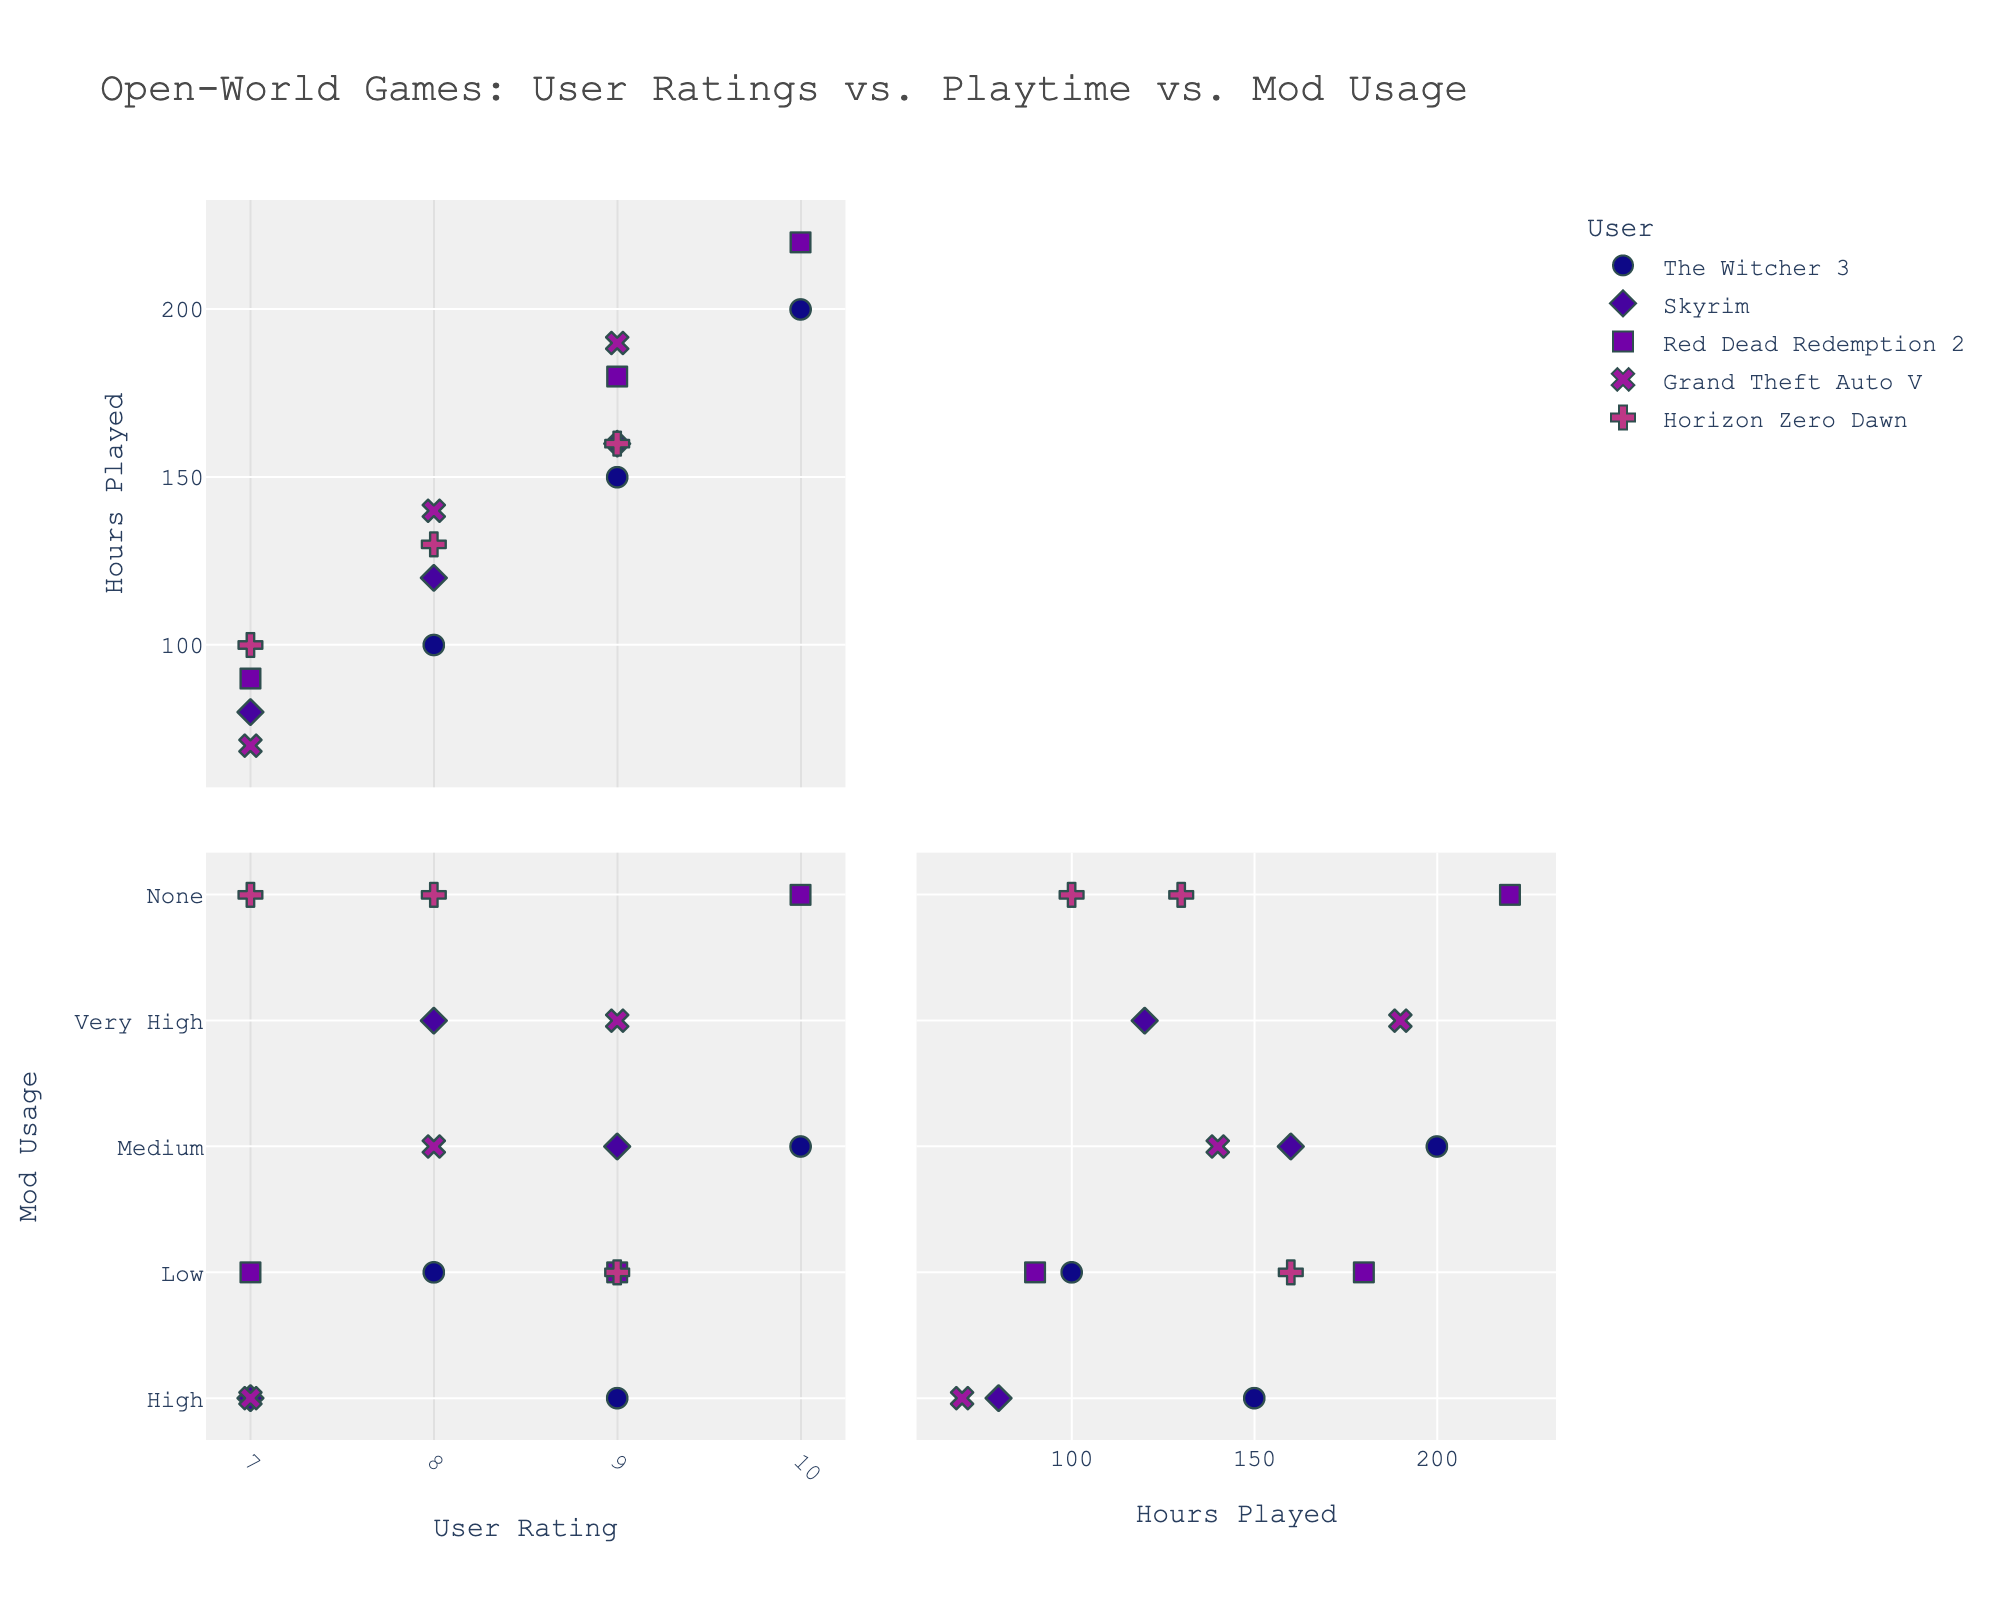How many games are represented in the plot? Look at the legend, which shows different symbols and colors representing each game. Count the number of unique game titles.
Answer: 5 Which game has the highest user rating? Look at the scatter plot matrix and identify the highest point on the 'User Rating' axis. Check the color and symbol associated with this data point to determine the game title.
Answer: The Witcher 3 Compare the average in-game hours played between "Skyrim" and "Red Dead Redemption 2". Which one is higher? Identify all points for Skyrim and Red Dead Redemption 2 on the 'In-Game_Hours_Played' axis, sum their hours, and divide by the number of points to get the average for each. Compare these averages.
Answer: Red Dead Redemption 2 Is there a visible trend between user ratings and in-game hours played for "The Witcher 3"? Look at the points corresponding to "The Witcher 3" and observe the relationship between the 'User Rating' and 'In-Game_Hours_Played'. Check if higher in-game hours correlate with higher user ratings.
Answer: Yes, a positive trend Which game shows the most diverse frequency of aesthetic mod usage? Identify the game that has data points spread across the most different categories of 'Frequency_of_Aesthetic_Mod_Usage' (None, Low, Medium, High, Very High).
Answer: Skyrim What is the user rating range for "Grand Theft Auto V"? Locate the 'Grand Theft Auto V' points in the scatter plot and identify the minimum and maximum values on the 'User Rating' axis.
Answer: 7-9 Do any games have a low frequency of aesthetic mod usage but high in-game hours played? Look for points categorized as 'Low' in 'Frequency_of_Aesthetic_Mod_Usage' and check their values on the 'In-Game_Hours_Played' axis for each game. Identify any with high in-game hours.
Answer: The Witcher 3 and Red Dead Redemption 2 Is there a game with high mod usage and a lower rating? Check points categorized as 'High' or 'Very High' in 'Frequency_of_Aesthetic_Mod_Usage' and verify if any of these points have lower values on the 'User Rating' axis.
Answer: Yes, Skyrim and Grand Theft Auto V Which game has the least variation in user ratings? Calculate the range of user ratings for each game and identify the game with the smallest range.
Answer: Horizon Zero Dawn How do the aesthetic mod usage frequencies compare between "The Witcher 3" and "Horizon Zero Dawn"? Compare the different categories of 'Frequency_of_Aesthetic_Mod_Usage' that "The Witcher 3" and "Horizon Zero Dawn" data points fall into.
Answer: The Witcher 3 uses more diverse mods 